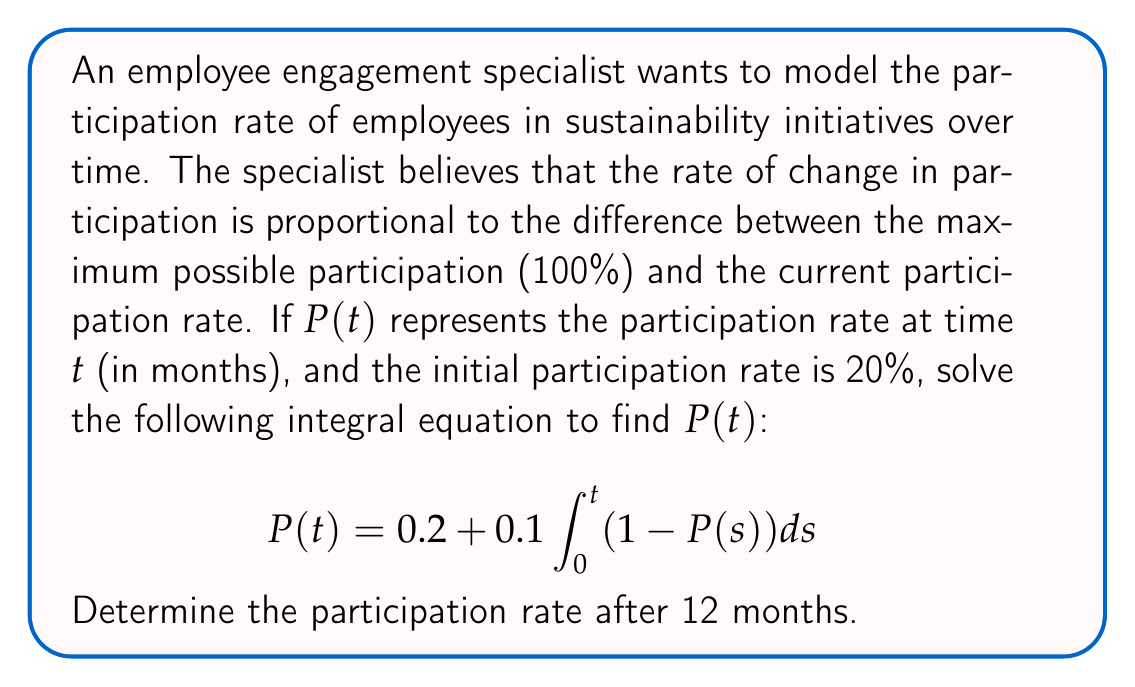Provide a solution to this math problem. To solve this integral equation, we'll use the following steps:

1) First, we recognize this as a Volterra integral equation of the second kind. We can solve it by differentiating both sides with respect to $t$:

   $$\frac{dP}{dt} = 0.1(1 - P(t))$$

2) This is now a separable differential equation. We can rewrite it as:

   $$\frac{dP}{1 - P} = 0.1dt$$

3) Integrating both sides:

   $$-\ln(1-P) = 0.1t + C$$

4) Solving for $P$:

   $$P = 1 - e^{-(0.1t + C)}$$

5) To find $C$, we use the initial condition $P(0) = 0.2$:

   $$0.2 = 1 - e^{-C}$$
   $$e^{-C} = 0.8$$
   $$C = -\ln(0.8)$$

6) Substituting this back into our solution:

   $$P(t) = 1 - e^{-(0.1t - \ln(0.8))}$$
   $$P(t) = 1 - 0.8e^{-0.1t}$$

7) To find the participation rate after 12 months, we calculate $P(12)$:

   $$P(12) = 1 - 0.8e^{-0.1(12)}$$
   $$P(12) = 1 - 0.8e^{-1.2}$$
   $$P(12) \approx 0.7385$$

Therefore, after 12 months, the participation rate will be approximately 73.85%.
Answer: $P(t) = 1 - 0.8e^{-0.1t}$; $P(12) \approx 0.7385$ or 73.85% 